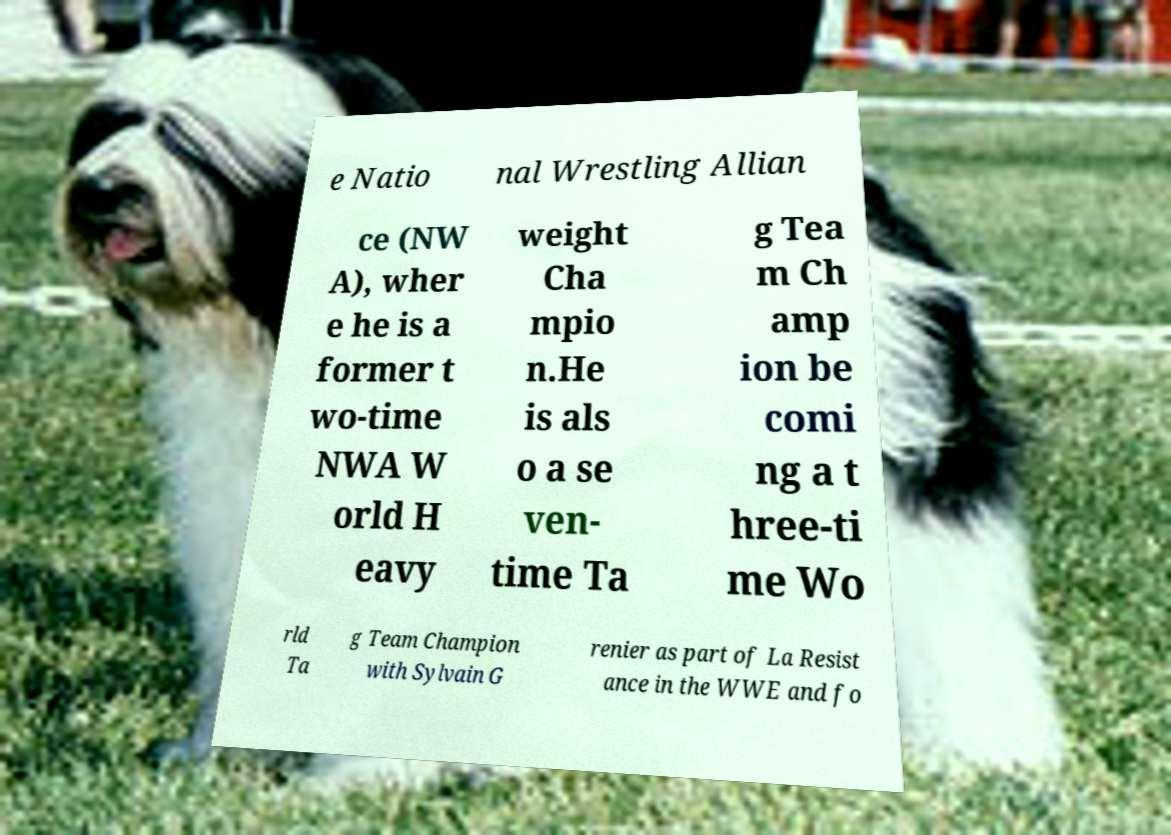Please read and relay the text visible in this image. What does it say? e Natio nal Wrestling Allian ce (NW A), wher e he is a former t wo-time NWA W orld H eavy weight Cha mpio n.He is als o a se ven- time Ta g Tea m Ch amp ion be comi ng a t hree-ti me Wo rld Ta g Team Champion with Sylvain G renier as part of La Resist ance in the WWE and fo 